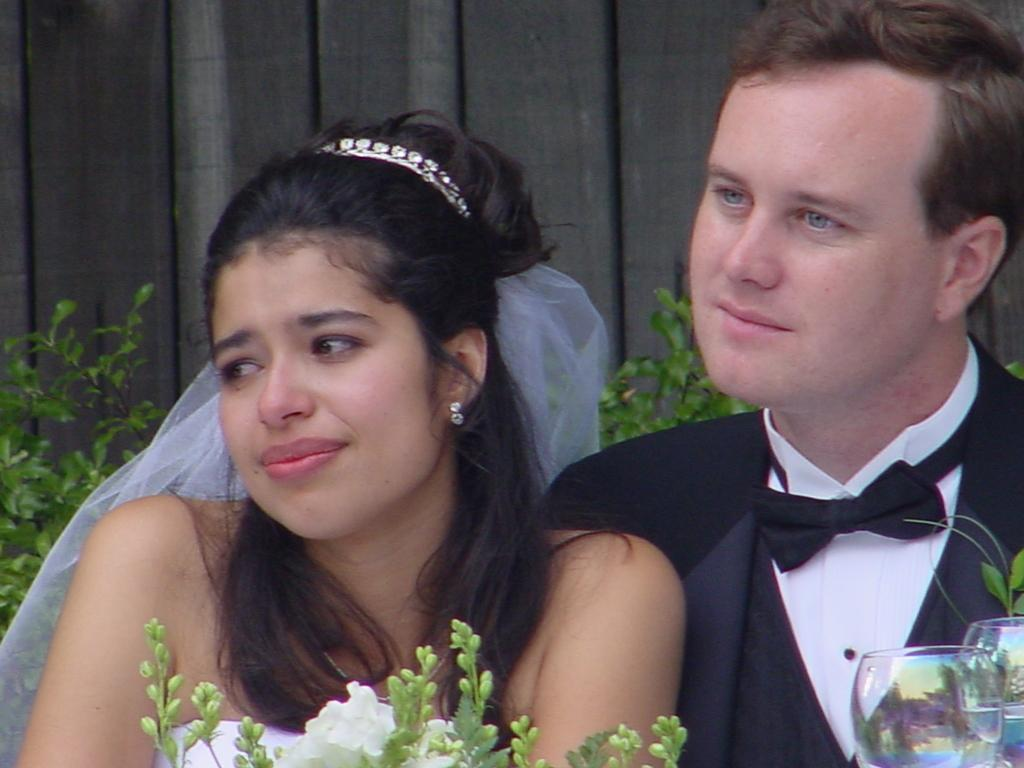How many people are present in the image? There are two people, a man and a woman, present in the image. What can be seen in the background of the image? There are plants and a wooden wall in the background of the image. Where are the glasses located in the image? The glasses are in the bottom right of the image. What object is in front of the woman? There is a book in front of the woman. What month is it in the image? The image does not provide any information about the month or time of year. What type of berry is being used as a cover for the book in the image? There is no berry present in the image, and the book does not have a cover made of berries. 